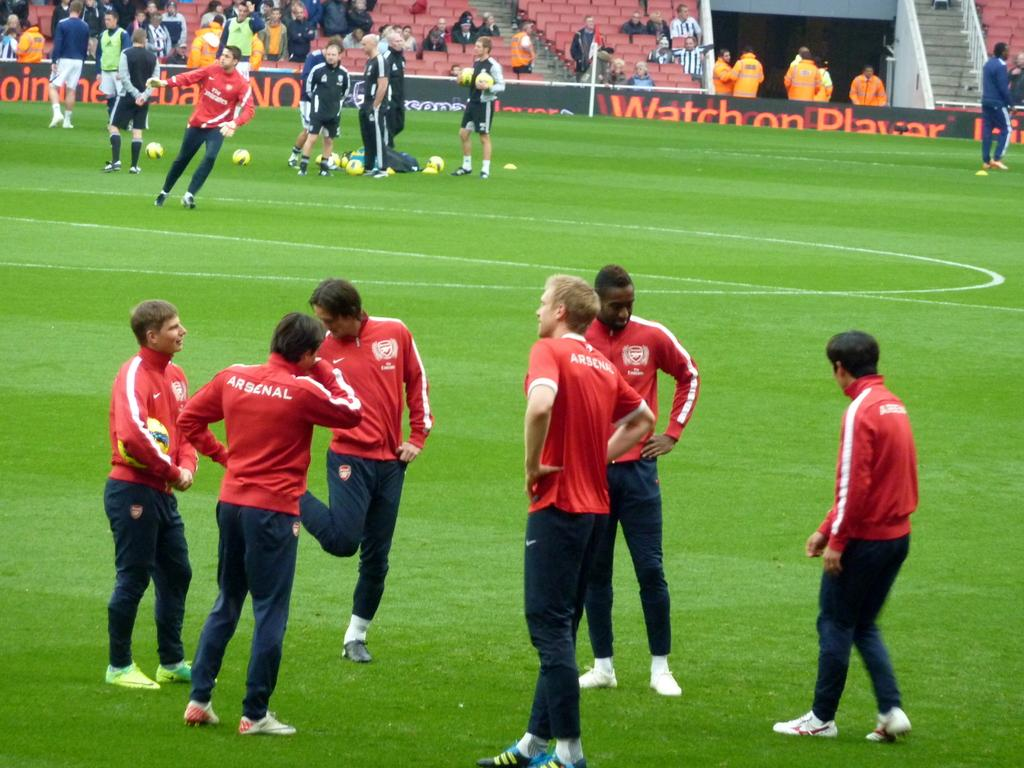What is happening in the image involving the group of people? There is a group of players in the image, suggesting they might be participating in a sporting event. How are the players positioned in the image? The players are standing in the image. What sport might be taking place in the image? The presence of footballs in the image suggests that it could be a football game. Who is watching the players in the image? There is an audience in the image, indicating that people are watching the event. How are the audience members seated in the image? The audience is seated on chairs in the image. What is the setting of the image? There is a green field ground in the image, which is a common setting for outdoor sports. What type of basin is being used by the players in the image? There is no basin present in the image; it features a group of players, footballs, an audience, and a green field ground. What is the relation between the players and the men in the image? There is no mention of men in the image; it only features a group of players and an audience. 